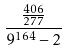<formula> <loc_0><loc_0><loc_500><loc_500>\frac { \frac { 4 0 6 } { 2 7 7 } } { 9 ^ { 1 6 4 } - 2 }</formula> 